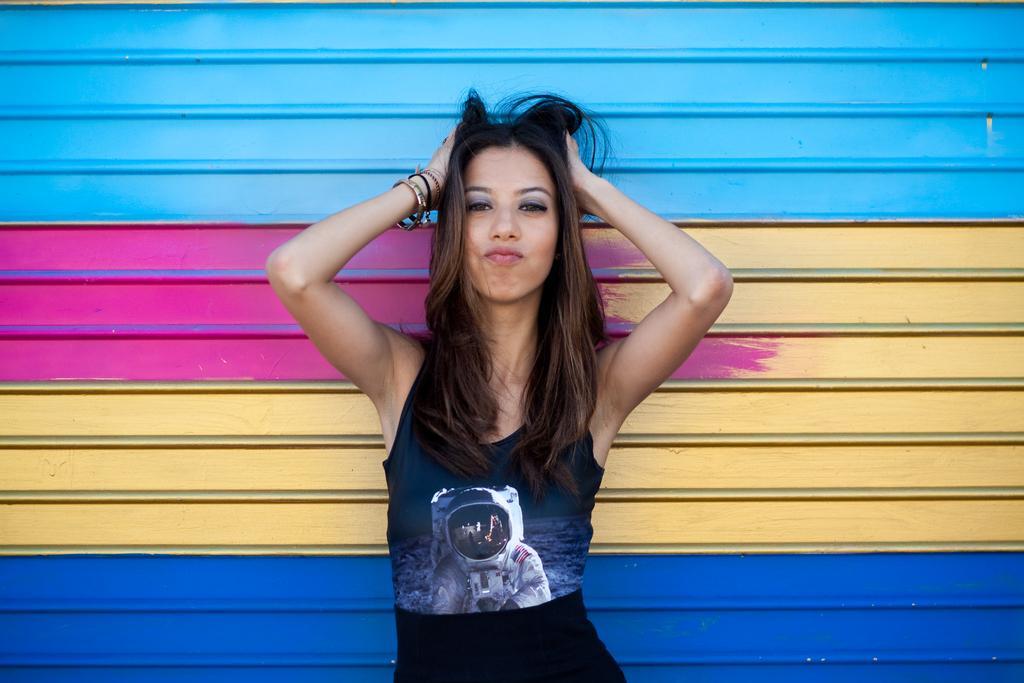In one or two sentences, can you explain what this image depicts? In this picture, there is a woman wearing a blue top and black trousers. In the background there is a wall with different colors. 